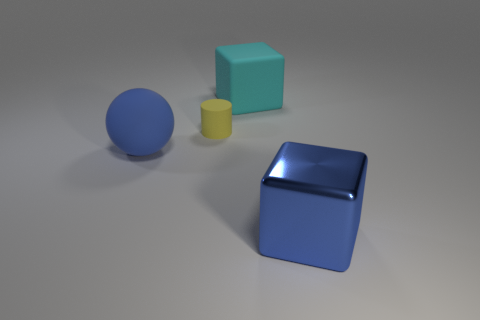How many cylinders are either big objects or tiny yellow things?
Your answer should be compact. 1. The blue sphere is what size?
Your response must be concise. Large. There is a yellow rubber thing; what number of large metallic things are behind it?
Provide a short and direct response. 0. How big is the blue thing right of the blue thing that is to the left of the metal cube?
Provide a short and direct response. Large. There is a object on the right side of the cyan matte object; is it the same shape as the large blue object to the left of the rubber block?
Offer a terse response. No. There is a large blue thing that is right of the big block that is behind the small rubber cylinder; what is its shape?
Provide a short and direct response. Cube. What is the size of the thing that is in front of the cyan cube and right of the tiny cylinder?
Give a very brief answer. Large. Is the shape of the large cyan object the same as the large blue object that is right of the small yellow thing?
Offer a terse response. Yes. What is the size of the matte object that is the same shape as the blue shiny thing?
Offer a terse response. Large. Is the color of the big rubber block the same as the large rubber thing left of the small thing?
Your answer should be compact. No. 